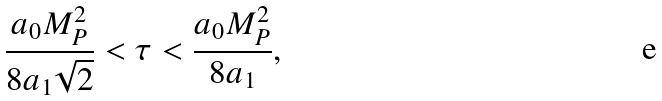<formula> <loc_0><loc_0><loc_500><loc_500>\frac { a _ { 0 } M _ { P } ^ { 2 } } { 8 a _ { 1 } \sqrt { 2 } } < \tau < \frac { a _ { 0 } M _ { P } ^ { 2 } } { 8 a _ { 1 } } ,</formula> 